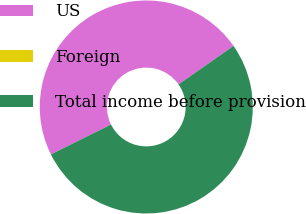Convert chart to OTSL. <chart><loc_0><loc_0><loc_500><loc_500><pie_chart><fcel>US<fcel>Foreign<fcel>Total income before provision<nl><fcel>47.62%<fcel>0.0%<fcel>52.38%<nl></chart> 